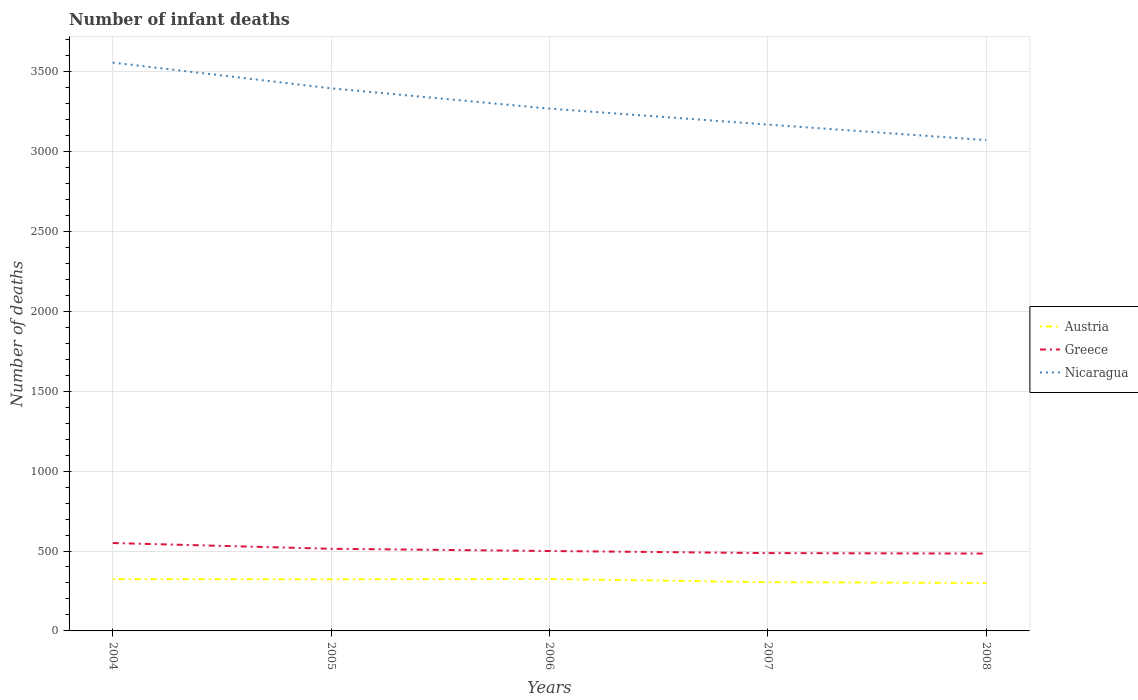Is the number of lines equal to the number of legend labels?
Give a very brief answer. Yes. Across all years, what is the maximum number of infant deaths in Greece?
Keep it short and to the point. 484. In which year was the number of infant deaths in Greece maximum?
Offer a terse response. 2008. What is the total number of infant deaths in Greece in the graph?
Make the answer very short. 36. What is the difference between the highest and the second highest number of infant deaths in Austria?
Offer a terse response. 25. What is the difference between the highest and the lowest number of infant deaths in Greece?
Provide a succinct answer. 2. What is the difference between two consecutive major ticks on the Y-axis?
Offer a very short reply. 500. Are the values on the major ticks of Y-axis written in scientific E-notation?
Provide a succinct answer. No. Does the graph contain grids?
Offer a very short reply. Yes. Where does the legend appear in the graph?
Give a very brief answer. Center right. How many legend labels are there?
Your response must be concise. 3. What is the title of the graph?
Offer a very short reply. Number of infant deaths. What is the label or title of the Y-axis?
Offer a terse response. Number of deaths. What is the Number of deaths in Austria in 2004?
Offer a very short reply. 324. What is the Number of deaths of Greece in 2004?
Make the answer very short. 550. What is the Number of deaths in Nicaragua in 2004?
Offer a very short reply. 3556. What is the Number of deaths in Austria in 2005?
Your answer should be very brief. 323. What is the Number of deaths of Greece in 2005?
Provide a short and direct response. 514. What is the Number of deaths of Nicaragua in 2005?
Offer a very short reply. 3395. What is the Number of deaths in Austria in 2006?
Make the answer very short. 325. What is the Number of deaths in Nicaragua in 2006?
Your answer should be very brief. 3268. What is the Number of deaths of Austria in 2007?
Provide a short and direct response. 305. What is the Number of deaths of Greece in 2007?
Provide a short and direct response. 487. What is the Number of deaths in Nicaragua in 2007?
Provide a succinct answer. 3168. What is the Number of deaths in Austria in 2008?
Your answer should be compact. 300. What is the Number of deaths of Greece in 2008?
Your answer should be very brief. 484. What is the Number of deaths in Nicaragua in 2008?
Your response must be concise. 3071. Across all years, what is the maximum Number of deaths of Austria?
Your answer should be very brief. 325. Across all years, what is the maximum Number of deaths in Greece?
Give a very brief answer. 550. Across all years, what is the maximum Number of deaths in Nicaragua?
Offer a terse response. 3556. Across all years, what is the minimum Number of deaths in Austria?
Keep it short and to the point. 300. Across all years, what is the minimum Number of deaths of Greece?
Give a very brief answer. 484. Across all years, what is the minimum Number of deaths of Nicaragua?
Offer a terse response. 3071. What is the total Number of deaths of Austria in the graph?
Give a very brief answer. 1577. What is the total Number of deaths of Greece in the graph?
Give a very brief answer. 2535. What is the total Number of deaths in Nicaragua in the graph?
Provide a short and direct response. 1.65e+04. What is the difference between the Number of deaths in Nicaragua in 2004 and that in 2005?
Offer a terse response. 161. What is the difference between the Number of deaths in Greece in 2004 and that in 2006?
Your answer should be compact. 50. What is the difference between the Number of deaths in Nicaragua in 2004 and that in 2006?
Offer a very short reply. 288. What is the difference between the Number of deaths in Nicaragua in 2004 and that in 2007?
Offer a very short reply. 388. What is the difference between the Number of deaths in Greece in 2004 and that in 2008?
Your answer should be very brief. 66. What is the difference between the Number of deaths of Nicaragua in 2004 and that in 2008?
Provide a short and direct response. 485. What is the difference between the Number of deaths of Austria in 2005 and that in 2006?
Provide a succinct answer. -2. What is the difference between the Number of deaths in Nicaragua in 2005 and that in 2006?
Provide a succinct answer. 127. What is the difference between the Number of deaths in Austria in 2005 and that in 2007?
Provide a short and direct response. 18. What is the difference between the Number of deaths in Nicaragua in 2005 and that in 2007?
Your response must be concise. 227. What is the difference between the Number of deaths of Greece in 2005 and that in 2008?
Keep it short and to the point. 30. What is the difference between the Number of deaths in Nicaragua in 2005 and that in 2008?
Make the answer very short. 324. What is the difference between the Number of deaths of Greece in 2006 and that in 2007?
Make the answer very short. 13. What is the difference between the Number of deaths in Nicaragua in 2006 and that in 2007?
Keep it short and to the point. 100. What is the difference between the Number of deaths of Austria in 2006 and that in 2008?
Make the answer very short. 25. What is the difference between the Number of deaths of Greece in 2006 and that in 2008?
Your answer should be compact. 16. What is the difference between the Number of deaths of Nicaragua in 2006 and that in 2008?
Give a very brief answer. 197. What is the difference between the Number of deaths of Austria in 2007 and that in 2008?
Give a very brief answer. 5. What is the difference between the Number of deaths of Greece in 2007 and that in 2008?
Keep it short and to the point. 3. What is the difference between the Number of deaths in Nicaragua in 2007 and that in 2008?
Offer a terse response. 97. What is the difference between the Number of deaths in Austria in 2004 and the Number of deaths in Greece in 2005?
Provide a short and direct response. -190. What is the difference between the Number of deaths in Austria in 2004 and the Number of deaths in Nicaragua in 2005?
Provide a succinct answer. -3071. What is the difference between the Number of deaths in Greece in 2004 and the Number of deaths in Nicaragua in 2005?
Offer a terse response. -2845. What is the difference between the Number of deaths of Austria in 2004 and the Number of deaths of Greece in 2006?
Keep it short and to the point. -176. What is the difference between the Number of deaths in Austria in 2004 and the Number of deaths in Nicaragua in 2006?
Offer a terse response. -2944. What is the difference between the Number of deaths in Greece in 2004 and the Number of deaths in Nicaragua in 2006?
Offer a terse response. -2718. What is the difference between the Number of deaths in Austria in 2004 and the Number of deaths in Greece in 2007?
Your response must be concise. -163. What is the difference between the Number of deaths in Austria in 2004 and the Number of deaths in Nicaragua in 2007?
Give a very brief answer. -2844. What is the difference between the Number of deaths in Greece in 2004 and the Number of deaths in Nicaragua in 2007?
Your answer should be very brief. -2618. What is the difference between the Number of deaths in Austria in 2004 and the Number of deaths in Greece in 2008?
Offer a very short reply. -160. What is the difference between the Number of deaths of Austria in 2004 and the Number of deaths of Nicaragua in 2008?
Provide a succinct answer. -2747. What is the difference between the Number of deaths of Greece in 2004 and the Number of deaths of Nicaragua in 2008?
Give a very brief answer. -2521. What is the difference between the Number of deaths in Austria in 2005 and the Number of deaths in Greece in 2006?
Keep it short and to the point. -177. What is the difference between the Number of deaths of Austria in 2005 and the Number of deaths of Nicaragua in 2006?
Offer a very short reply. -2945. What is the difference between the Number of deaths of Greece in 2005 and the Number of deaths of Nicaragua in 2006?
Offer a terse response. -2754. What is the difference between the Number of deaths of Austria in 2005 and the Number of deaths of Greece in 2007?
Ensure brevity in your answer.  -164. What is the difference between the Number of deaths of Austria in 2005 and the Number of deaths of Nicaragua in 2007?
Give a very brief answer. -2845. What is the difference between the Number of deaths of Greece in 2005 and the Number of deaths of Nicaragua in 2007?
Give a very brief answer. -2654. What is the difference between the Number of deaths in Austria in 2005 and the Number of deaths in Greece in 2008?
Make the answer very short. -161. What is the difference between the Number of deaths in Austria in 2005 and the Number of deaths in Nicaragua in 2008?
Provide a succinct answer. -2748. What is the difference between the Number of deaths in Greece in 2005 and the Number of deaths in Nicaragua in 2008?
Your response must be concise. -2557. What is the difference between the Number of deaths in Austria in 2006 and the Number of deaths in Greece in 2007?
Provide a succinct answer. -162. What is the difference between the Number of deaths of Austria in 2006 and the Number of deaths of Nicaragua in 2007?
Ensure brevity in your answer.  -2843. What is the difference between the Number of deaths of Greece in 2006 and the Number of deaths of Nicaragua in 2007?
Your answer should be very brief. -2668. What is the difference between the Number of deaths of Austria in 2006 and the Number of deaths of Greece in 2008?
Provide a short and direct response. -159. What is the difference between the Number of deaths in Austria in 2006 and the Number of deaths in Nicaragua in 2008?
Your answer should be very brief. -2746. What is the difference between the Number of deaths of Greece in 2006 and the Number of deaths of Nicaragua in 2008?
Keep it short and to the point. -2571. What is the difference between the Number of deaths in Austria in 2007 and the Number of deaths in Greece in 2008?
Your response must be concise. -179. What is the difference between the Number of deaths in Austria in 2007 and the Number of deaths in Nicaragua in 2008?
Your answer should be compact. -2766. What is the difference between the Number of deaths in Greece in 2007 and the Number of deaths in Nicaragua in 2008?
Provide a short and direct response. -2584. What is the average Number of deaths of Austria per year?
Give a very brief answer. 315.4. What is the average Number of deaths of Greece per year?
Your answer should be very brief. 507. What is the average Number of deaths of Nicaragua per year?
Make the answer very short. 3291.6. In the year 2004, what is the difference between the Number of deaths in Austria and Number of deaths in Greece?
Your answer should be very brief. -226. In the year 2004, what is the difference between the Number of deaths of Austria and Number of deaths of Nicaragua?
Provide a short and direct response. -3232. In the year 2004, what is the difference between the Number of deaths of Greece and Number of deaths of Nicaragua?
Your response must be concise. -3006. In the year 2005, what is the difference between the Number of deaths in Austria and Number of deaths in Greece?
Provide a succinct answer. -191. In the year 2005, what is the difference between the Number of deaths in Austria and Number of deaths in Nicaragua?
Offer a terse response. -3072. In the year 2005, what is the difference between the Number of deaths in Greece and Number of deaths in Nicaragua?
Provide a succinct answer. -2881. In the year 2006, what is the difference between the Number of deaths in Austria and Number of deaths in Greece?
Provide a short and direct response. -175. In the year 2006, what is the difference between the Number of deaths in Austria and Number of deaths in Nicaragua?
Make the answer very short. -2943. In the year 2006, what is the difference between the Number of deaths of Greece and Number of deaths of Nicaragua?
Give a very brief answer. -2768. In the year 2007, what is the difference between the Number of deaths of Austria and Number of deaths of Greece?
Offer a very short reply. -182. In the year 2007, what is the difference between the Number of deaths of Austria and Number of deaths of Nicaragua?
Keep it short and to the point. -2863. In the year 2007, what is the difference between the Number of deaths of Greece and Number of deaths of Nicaragua?
Offer a terse response. -2681. In the year 2008, what is the difference between the Number of deaths in Austria and Number of deaths in Greece?
Keep it short and to the point. -184. In the year 2008, what is the difference between the Number of deaths in Austria and Number of deaths in Nicaragua?
Your answer should be very brief. -2771. In the year 2008, what is the difference between the Number of deaths in Greece and Number of deaths in Nicaragua?
Your answer should be very brief. -2587. What is the ratio of the Number of deaths of Austria in 2004 to that in 2005?
Ensure brevity in your answer.  1. What is the ratio of the Number of deaths of Greece in 2004 to that in 2005?
Provide a short and direct response. 1.07. What is the ratio of the Number of deaths of Nicaragua in 2004 to that in 2005?
Make the answer very short. 1.05. What is the ratio of the Number of deaths in Austria in 2004 to that in 2006?
Your answer should be very brief. 1. What is the ratio of the Number of deaths in Nicaragua in 2004 to that in 2006?
Keep it short and to the point. 1.09. What is the ratio of the Number of deaths of Austria in 2004 to that in 2007?
Ensure brevity in your answer.  1.06. What is the ratio of the Number of deaths of Greece in 2004 to that in 2007?
Provide a succinct answer. 1.13. What is the ratio of the Number of deaths of Nicaragua in 2004 to that in 2007?
Provide a succinct answer. 1.12. What is the ratio of the Number of deaths in Greece in 2004 to that in 2008?
Keep it short and to the point. 1.14. What is the ratio of the Number of deaths of Nicaragua in 2004 to that in 2008?
Your answer should be very brief. 1.16. What is the ratio of the Number of deaths of Austria in 2005 to that in 2006?
Ensure brevity in your answer.  0.99. What is the ratio of the Number of deaths of Greece in 2005 to that in 2006?
Keep it short and to the point. 1.03. What is the ratio of the Number of deaths of Nicaragua in 2005 to that in 2006?
Provide a succinct answer. 1.04. What is the ratio of the Number of deaths of Austria in 2005 to that in 2007?
Your response must be concise. 1.06. What is the ratio of the Number of deaths of Greece in 2005 to that in 2007?
Your answer should be compact. 1.06. What is the ratio of the Number of deaths in Nicaragua in 2005 to that in 2007?
Give a very brief answer. 1.07. What is the ratio of the Number of deaths of Austria in 2005 to that in 2008?
Give a very brief answer. 1.08. What is the ratio of the Number of deaths of Greece in 2005 to that in 2008?
Give a very brief answer. 1.06. What is the ratio of the Number of deaths in Nicaragua in 2005 to that in 2008?
Offer a very short reply. 1.11. What is the ratio of the Number of deaths of Austria in 2006 to that in 2007?
Your answer should be very brief. 1.07. What is the ratio of the Number of deaths of Greece in 2006 to that in 2007?
Ensure brevity in your answer.  1.03. What is the ratio of the Number of deaths of Nicaragua in 2006 to that in 2007?
Offer a very short reply. 1.03. What is the ratio of the Number of deaths of Austria in 2006 to that in 2008?
Give a very brief answer. 1.08. What is the ratio of the Number of deaths of Greece in 2006 to that in 2008?
Provide a succinct answer. 1.03. What is the ratio of the Number of deaths in Nicaragua in 2006 to that in 2008?
Provide a succinct answer. 1.06. What is the ratio of the Number of deaths of Austria in 2007 to that in 2008?
Your answer should be very brief. 1.02. What is the ratio of the Number of deaths of Greece in 2007 to that in 2008?
Offer a terse response. 1.01. What is the ratio of the Number of deaths of Nicaragua in 2007 to that in 2008?
Make the answer very short. 1.03. What is the difference between the highest and the second highest Number of deaths in Nicaragua?
Give a very brief answer. 161. What is the difference between the highest and the lowest Number of deaths in Austria?
Keep it short and to the point. 25. What is the difference between the highest and the lowest Number of deaths in Greece?
Provide a short and direct response. 66. What is the difference between the highest and the lowest Number of deaths in Nicaragua?
Your response must be concise. 485. 